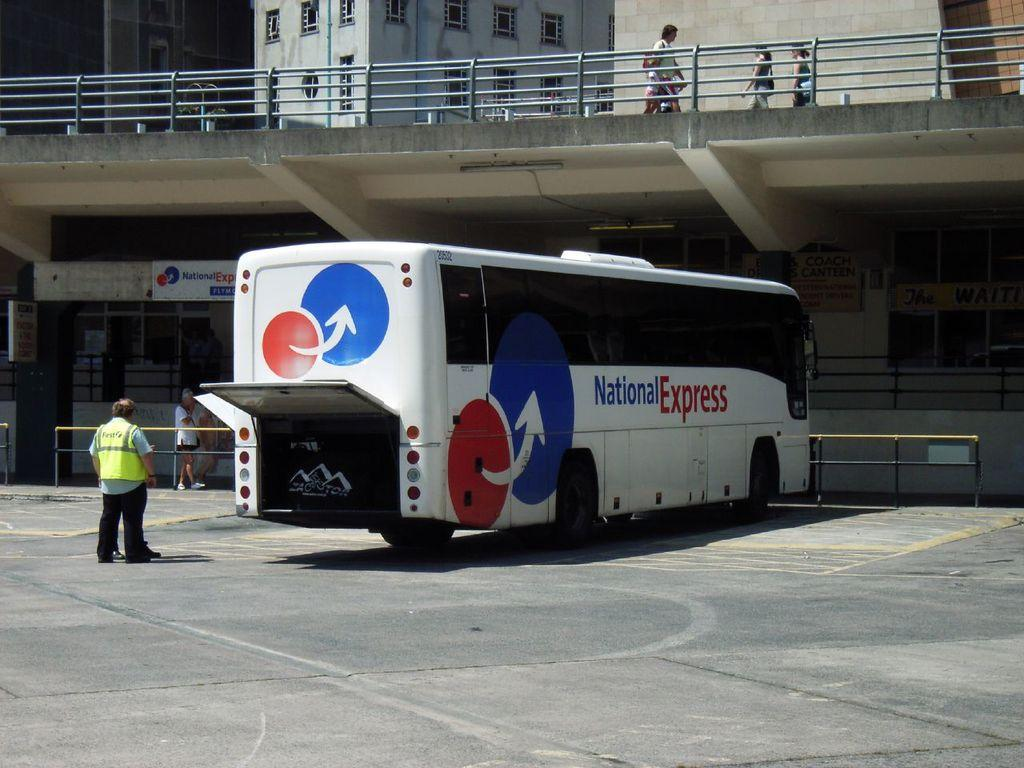What is the main subject of the picture? The main subject of the picture is a bus. Can you describe the person in the picture? There is a person standing behind the bus. What can be seen in the foreground of the picture? There is a railing in the picture. What is visible in the background of the picture? There is a building in the background of the picture. How many fairies are sitting on the bus in the image? There are no fairies present in the image. What type of egg can be seen in the picture? There is no egg present in the image. 